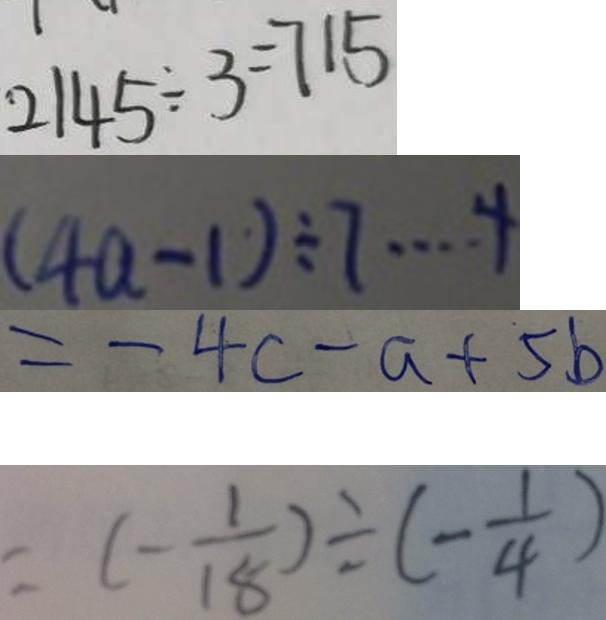Convert formula to latex. <formula><loc_0><loc_0><loc_500><loc_500>2 1 4 5 \div 3 = 7 1 5 
 ( 4 a - 1 ) \div 7 \cdots 4 
 = - 4 c - a + 5 b 
 = ( - \frac { 1 } { 1 8 } ) \div ( - \frac { 1 } { 4 } )</formula> 